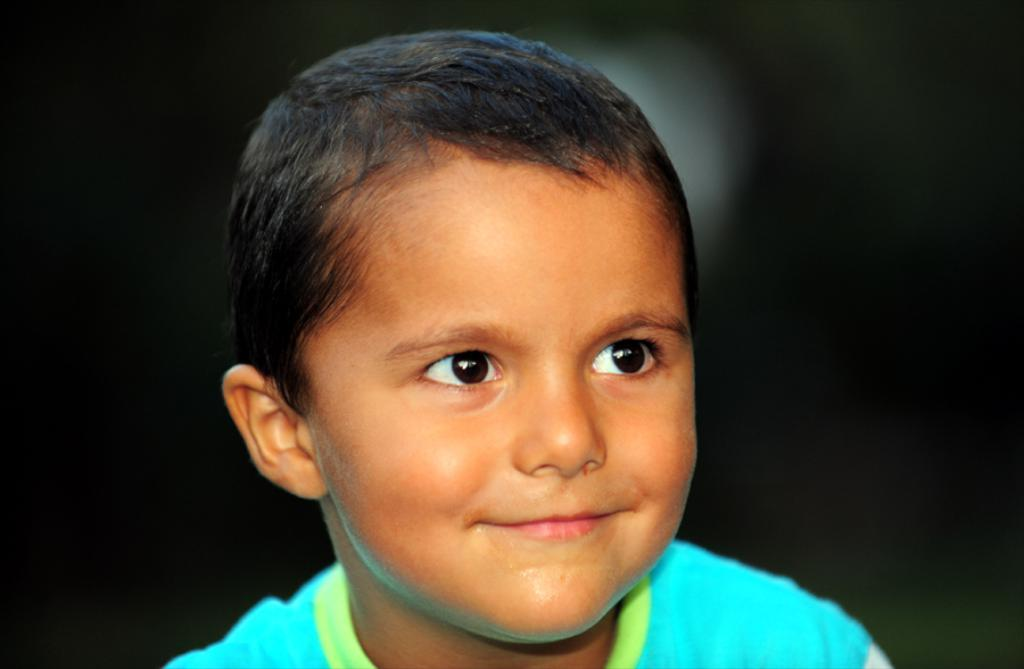What is the main subject of the image? There is a boy in the image. What is the boy wearing? The boy is wearing a t-shirt. What is the boy's facial expression? The boy is smiling. In which direction is the boy looking? The boy is looking to the right side. What color is the background of the image? The background of the image is black. How many times does the boy sneeze in the image? The boy does not sneeze in the image; he is smiling. What is the amount of water in the lake visible in the image? There is no lake present in the image, so it is not possible to determine the amount of water. 